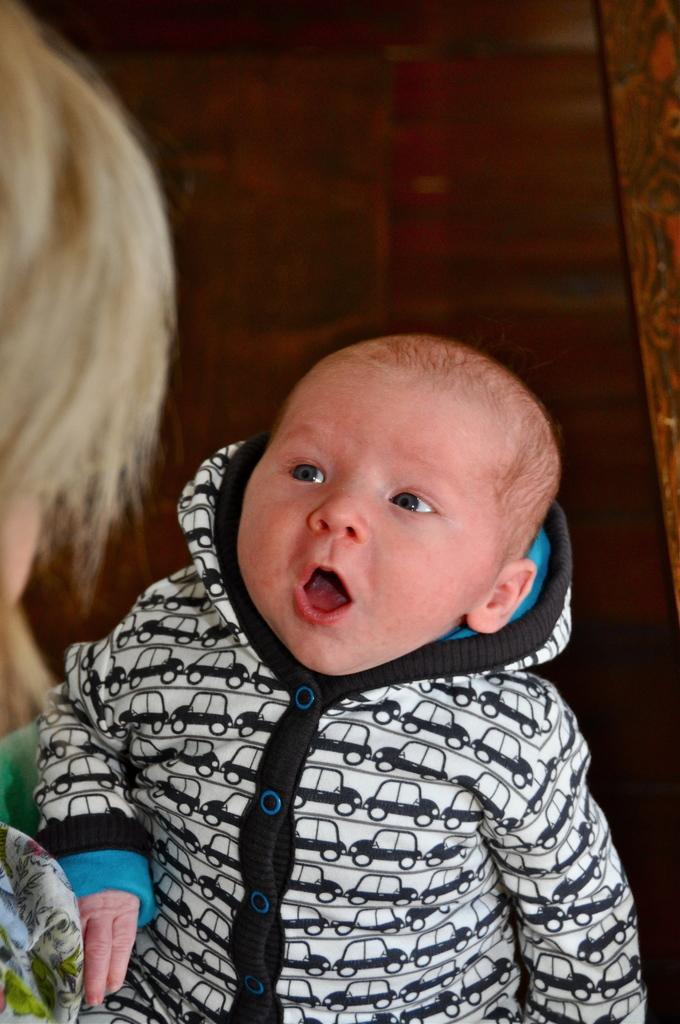Please provide a concise description of this image. In this image I can see a boy and I can see he is wearing a black and white colour hoodie. On the left side of this image I can see one person and I can also see brown colour in the background. 